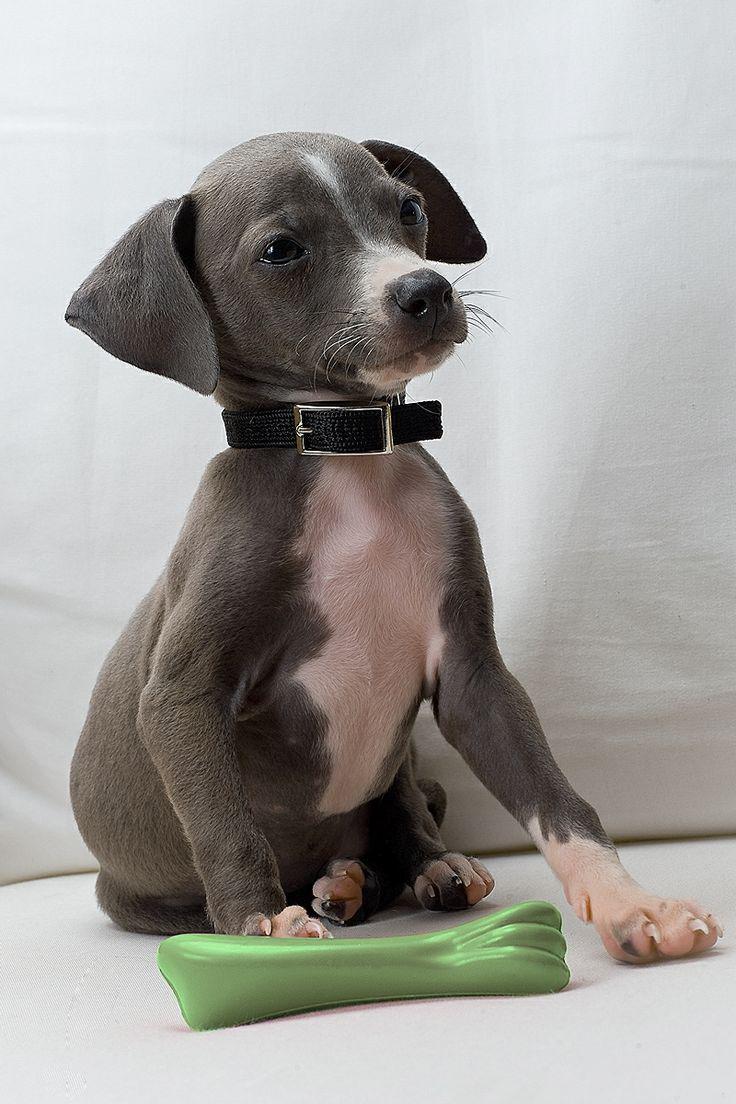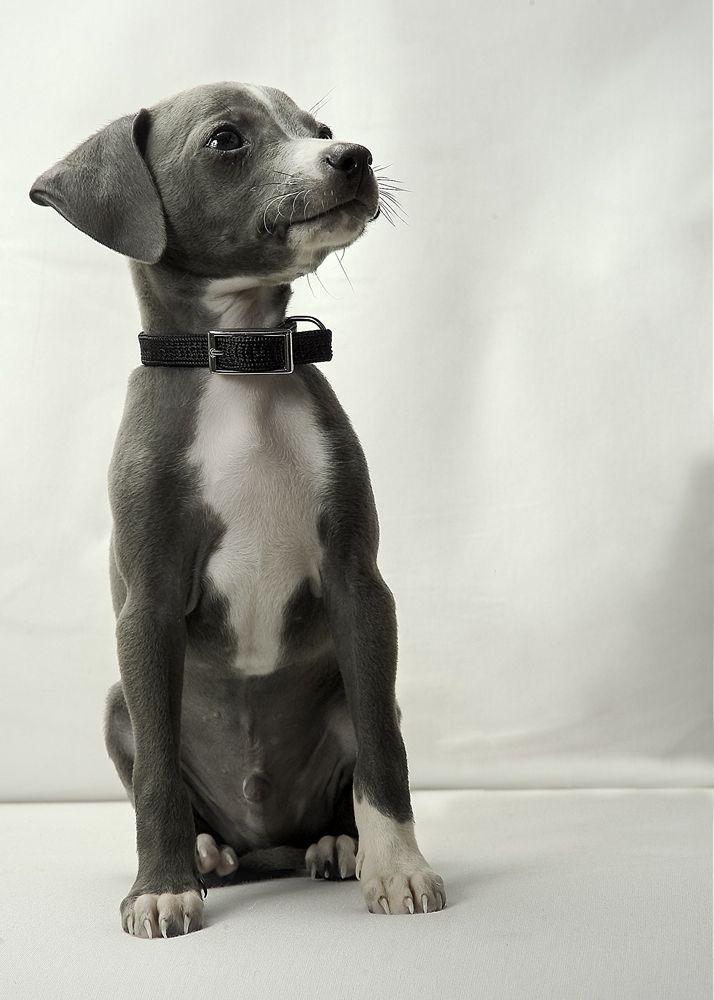The first image is the image on the left, the second image is the image on the right. Considering the images on both sides, is "Left and right images each contain one similarly posed and sized dog." valid? Answer yes or no. Yes. The first image is the image on the left, the second image is the image on the right. For the images displayed, is the sentence "At least one image shows a single dog standing up with only paws touching the ground." factually correct? Answer yes or no. No. 